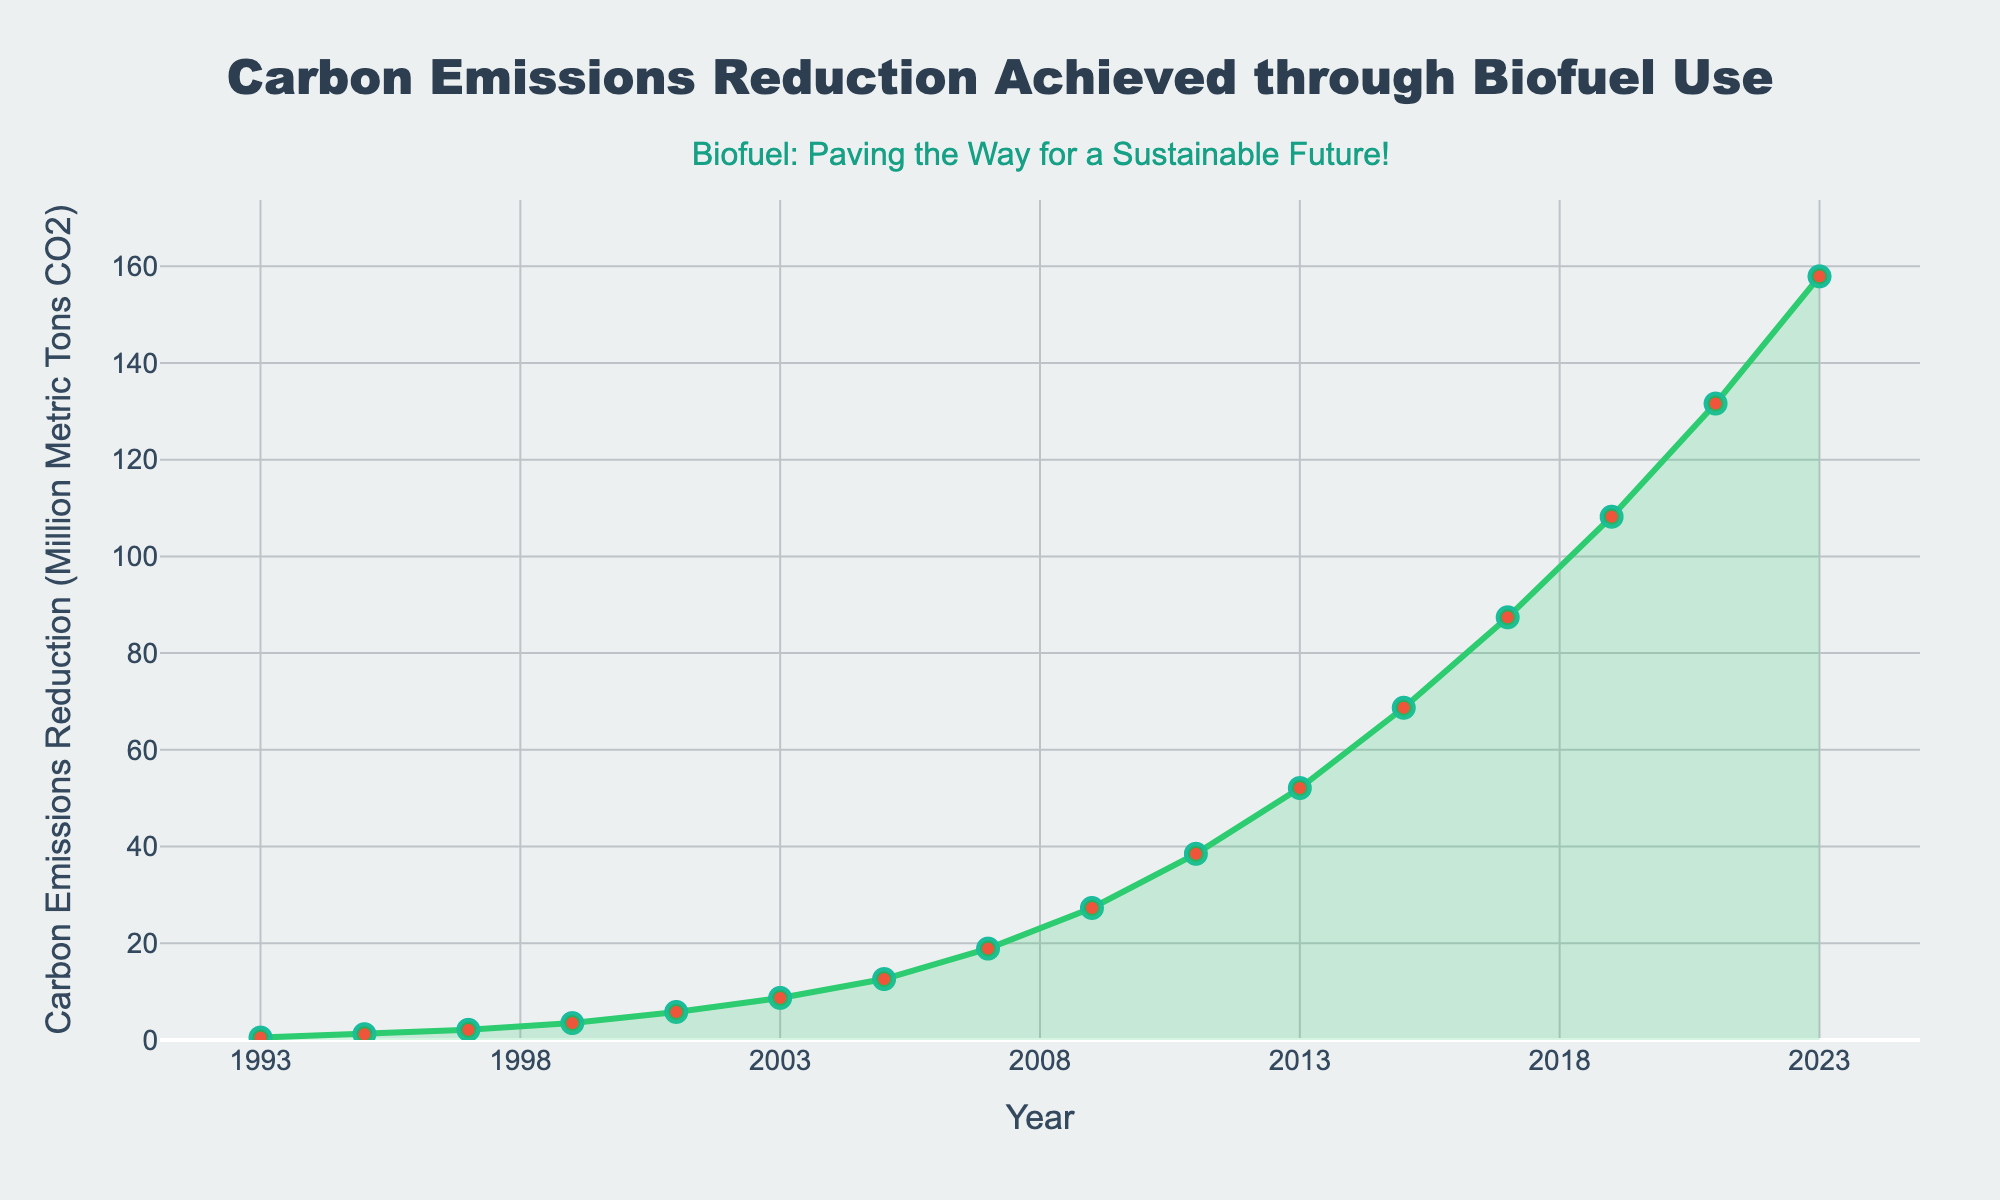What was the value of carbon emissions reduction in 2013? To find the carbon emissions reduction in 2013, locate the point on the graph for the year 2013. The corresponding value cited is 52.1 million metric tons of CO2.
Answer: 52.1 million metric tons In which year was the increase in carbon emissions reduction higher between 2011 and 2013 or between 2013 and 2015? Calculate the increase for both periods: between 2011 and 2013, the increase is 52.1 - 38.5 = 13.6 million metric tons. Between 2013 and 2015, the increase is 68.7 - 52.1 = 16.6 million metric tons. Comparing 13.6 and 16.6, the increase was higher between 2013 and 2015.
Answer: Between 2013 and 2015 What is the average annual increase in carbon emissions reduction from 1993 to 2023? To determine the average annual increase, first find the total increase: 157.9 (2023) - 0.5 (1993) = 157.4 million metric tons. The time span is 30 years. Calculate the average annual increase: 157.4 / 30 ≈ 5.25 million metric tons.
Answer: 5.25 million metric tons By how much did carbon emissions reduction increase from 1997 to 2007? Identify the reduction values for 1997 and 2007: 2.1 million metric tons (1997) and 18.9 million metric tons (2007). Compute the difference: 18.9 - 2.1 = 16.8 million metric tons.
Answer: 16.8 million metric tons Which year shows the steepest increase in carbon emissions reduction? A steep increase is represented by a steep slope in a line chart. Visually identify the segment with the steepest slope, which appears between 2017 and 2019. Verify the change: 108.2 (2019) - 87.4 (2017) = 20.8 million metric tons.
Answer: Between 2017 and 2019 Is there any year where the carbon emissions reduction remained the same as the previous year? Observe the line chart to see if there is any segment where the line is horizontal, indicating no change. No horizontal segments appear, thus the value changes every year.
Answer: No Where in the graph can you find the annotation "Biofuel: Paving the Way for a Sustainable Future!"? This annotation visually appears at the top-center of the graph, just above the title "Carbon Emissions Reduction Achieved through Biofuel Use".
Answer: Top-center above the title 